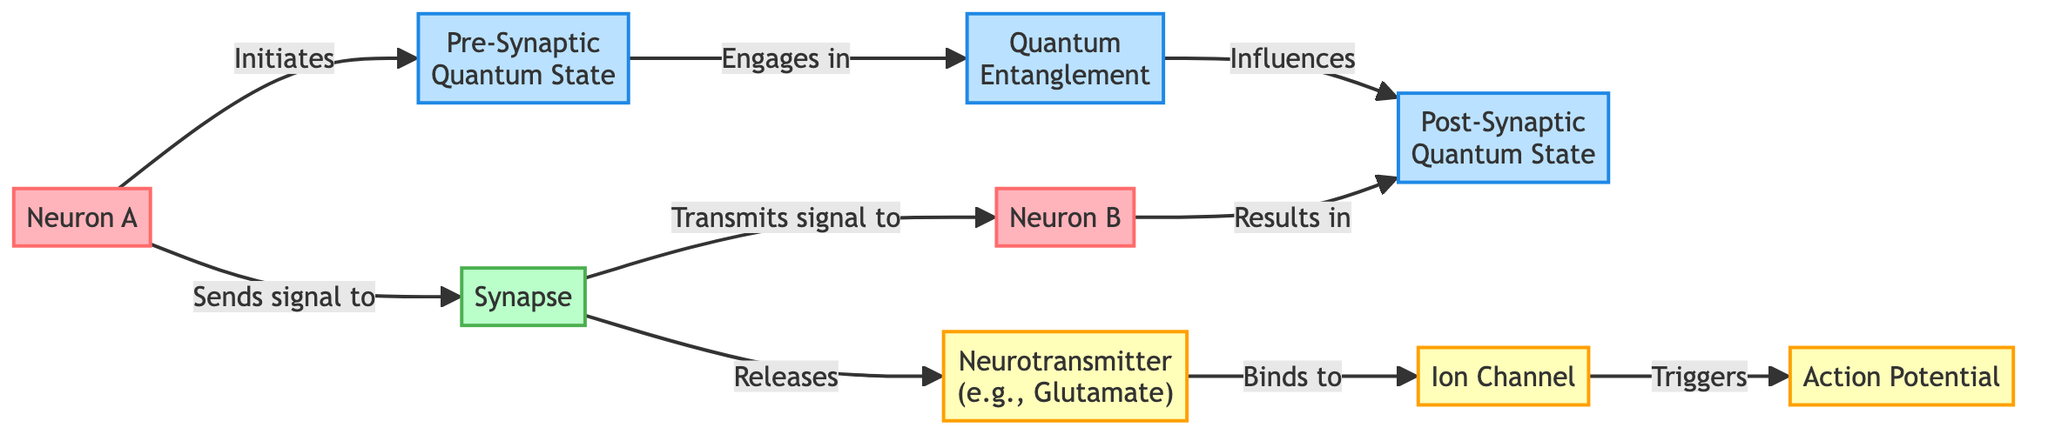What are the two neurons depicted in the diagram? The diagram shows two neurons labeled "Neuron A" and "Neuron B."
Answer: Neuron A, Neuron B What does the synapse transmit? The synapse transmits the signal from "Neuron A" to "Neuron B."
Answer: Signal How many quantum states are present in the diagram? There are two quantum states shown: "Pre-Synaptic Quantum State" and "Post-Synaptic Quantum State."
Answer: Two What role does the neurotransmitter play in the diagram? The neurotransmitter releases from the synapse and binds to the ion channel, triggering the action potential.
Answer: Releases Which component influences the post-synaptic quantum state? The "Quantum Entanglement" influences the post-synaptic quantum state according to the flow of the diagram.
Answer: Quantum Entanglement What is released by the synapse? The synapse releases a neurotransmitter, specifically identified as "Neurotransmitter (e.g., Glutamate)" in the diagram.
Answer: Neurotransmitter What is the action resulting from the ion channel's activation? The activation of the ion channel triggers an action potential. This is a key event following the binding of the neurotransmitter.
Answer: Action Potential In the flow from Neuron A to Neuron B, how is the transmission initially initiated? The transmission is initiated when "Neuron A" sends a signal to the synapse.
Answer: Sends signal What type of interaction occurs between the pre-synaptic and post-synaptic states? The interaction is characterized as quantum entanglement, indicating a deeper connection between the two states.
Answer: Quantum Entanglement 